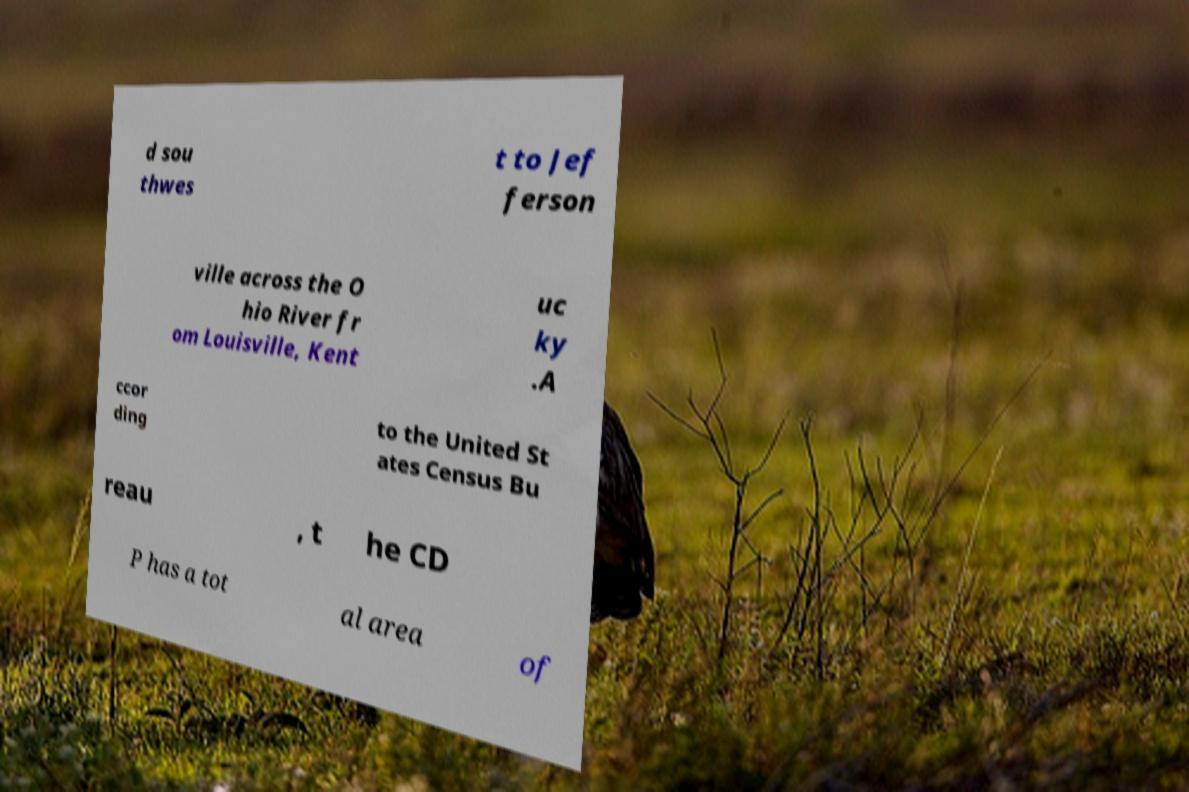Please identify and transcribe the text found in this image. d sou thwes t to Jef ferson ville across the O hio River fr om Louisville, Kent uc ky .A ccor ding to the United St ates Census Bu reau , t he CD P has a tot al area of 